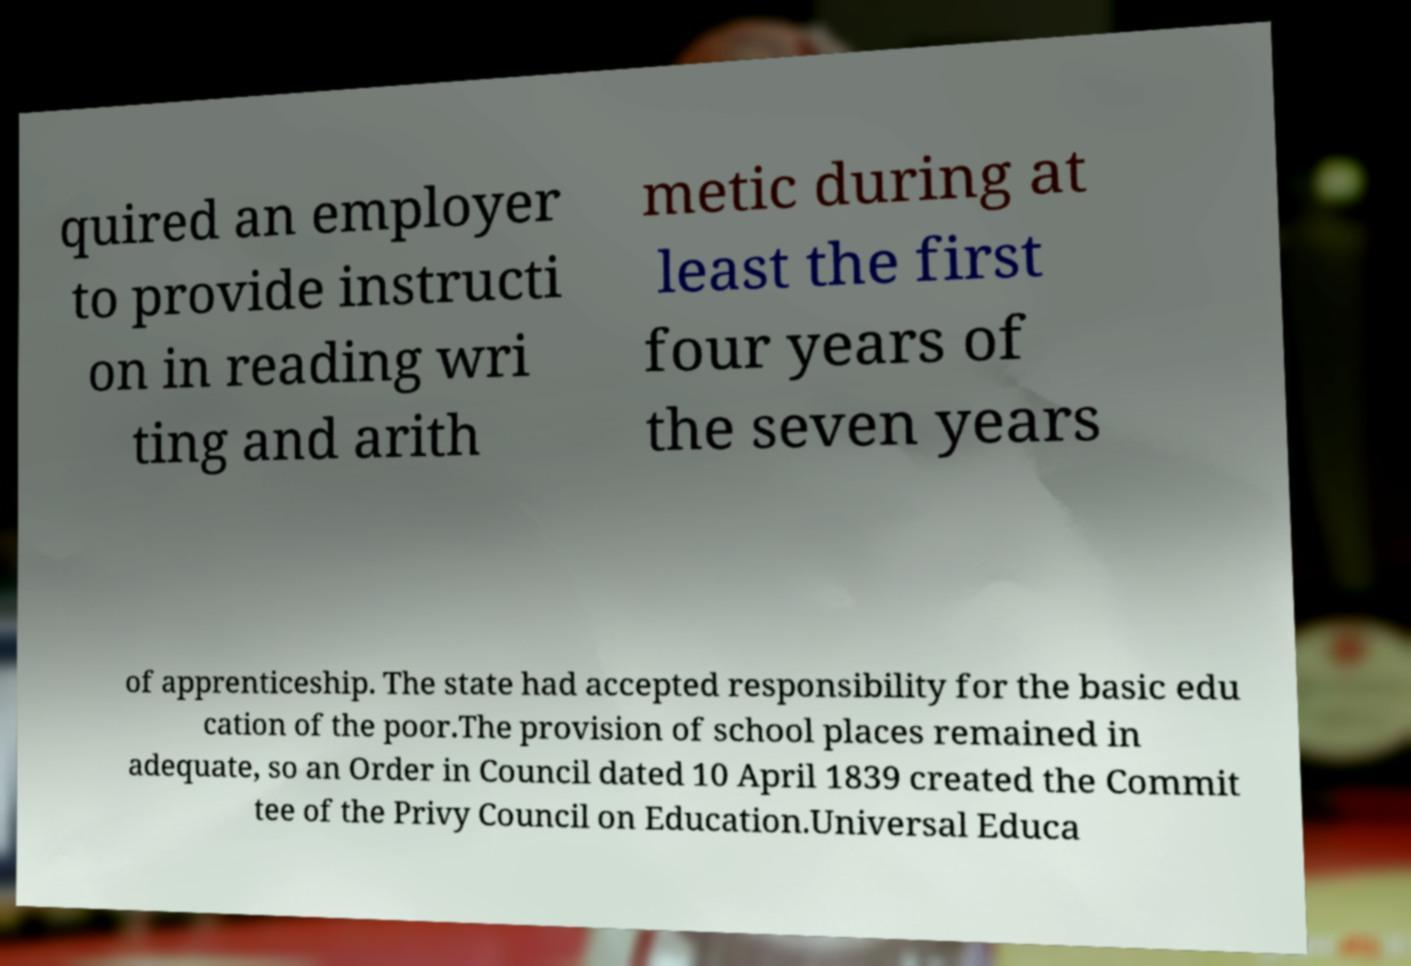Please read and relay the text visible in this image. What does it say? quired an employer to provide instructi on in reading wri ting and arith metic during at least the first four years of the seven years of apprenticeship. The state had accepted responsibility for the basic edu cation of the poor.The provision of school places remained in adequate, so an Order in Council dated 10 April 1839 created the Commit tee of the Privy Council on Education.Universal Educa 